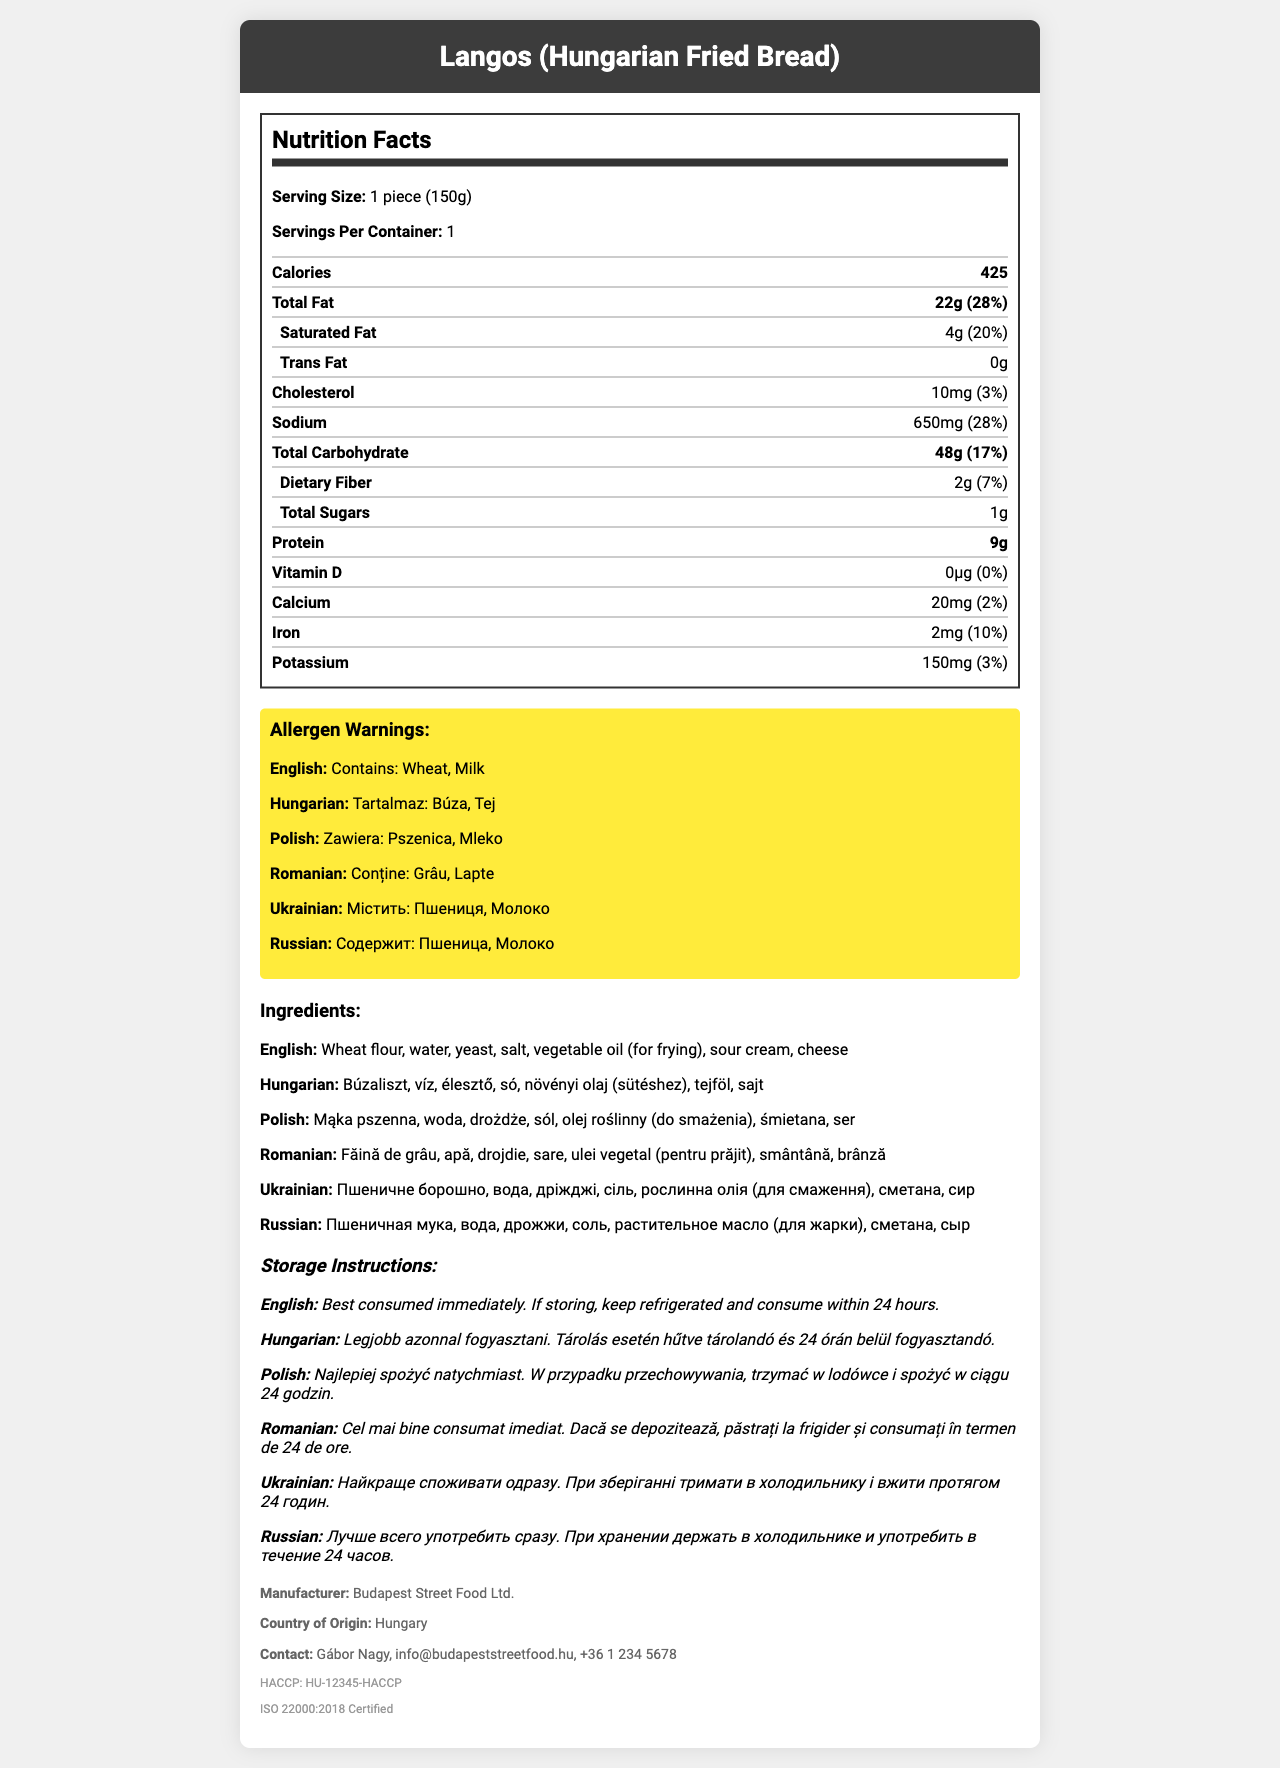what is the serving size of the Langos? The serving size is listed under the section "Serving Size" which states "1 piece (150g)".
Answer: 1 piece (150g) how many calories are in one serving of Langos? The document under the "Nutrition Facts" section shows the calorie content as 425.
Answer: 425 what is the total fat content and its daily value percentage? The "Total Fat" entry under the "Nutrition Facts" section shows 22 grams and a daily value percentage of 28%.
Answer: 22g (28%) which allergens are present in the Langos according to the Hungarian warning? The allergen warning in Hungarian states "Tartalmaz: Búza, Tej".
Answer: Búza, Tej what is the manufacturer's contact email? The contact information listed under the "manufacturer" section includes the email "info@budapeststreetfood.hu".
Answer: info@budapeststreetfood.hu how much sodium does one serving of Langos contain? The sodium content listed under the "Nutrition Facts" section is 650 milligrams.
Answer: 650mg which vitamin or mineral has the highest daily value percentage? A. Vitamin D B. Calcium C. Iron D. Potassium The Iron entry under the "Nutrition Facts" section has a daily value percent of 10%, which is the highest among Vitamin D, Calcium, and Potassium.
Answer: C. Iron what is the recommended storage instruction in Polish? The recommended storage instructions in Polish state, "Trzymać w lodówce i spożyć w ciągu 24 godzin."
Answer: Trzymać w lodówce i spożyć w ciągu 24 godzin. does the Langos contain trans fat? The "Trans Fat" entry under the "Nutrition Facts" section lists 0 grams, indicating it does not contain trans fat.
Answer: No who is the business contact named in the document? The business contact listed is Gábor Nagy.
Answer: Gábor Nagy is the "Budapest Street Food Ltd." company certified? If so, to which standards? The certification section lists "HACCP: HU-12345-HACCP" and "ISO 22000:2018 Certified".
Answer: Yes, HACCP and ISO 22000 what is the primary ingredient listed in the Hungarian ingredient list? A. Növényi olaj B. Búzaliszt C. Tejföl D. Víz The Hungarian ingredient list starts with "Búzaliszt", meaning wheat flour.
Answer: B. Búzaliszt how many servings are in one container of Langos? The "Servings Per Container" information lists 1 serving per container.
Answer: 1 summarize the entire document. The document covers multiple aspects of the nutritional profile and regulatory compliances for Langos, providing comprehensive information valuable for consumers.
Answer: The document is a detailed nutrition facts label for "Langos (Hungarian Fried Bread)" provided by Budapest Street Food Ltd. It includes nutritional information, allergen warnings in multiple languages, a list of ingredients in various languages, storage instructions, manufacturer details, and certifications. The serving size is one piece of 150g, containing 425 calories, 22g of total fat, and other nutritional breakdowns. Allergen warnings mention wheat and milk in several languages. how long can Langos be stored according to the document? The storage instructions state that it should be consumed within 24 hours if stored in the refrigerator.
Answer: 24 hours what is the vitamin D content in micrograms and its daily value percentage? The "Vitamin D" entry under the "Nutrition Facts" section lists 0 micrograms and a daily value percentage of 0%.
Answer: 0µg (0%) are there any allergens mentioned in the English warning? The English allergen warning mentions Wheat and Milk.
Answer: Yes can we determine the price of Langos from this document? The document contains nutritional information, ingredients, and other details, but it does not provide pricing information.
Answer: Not enough information 